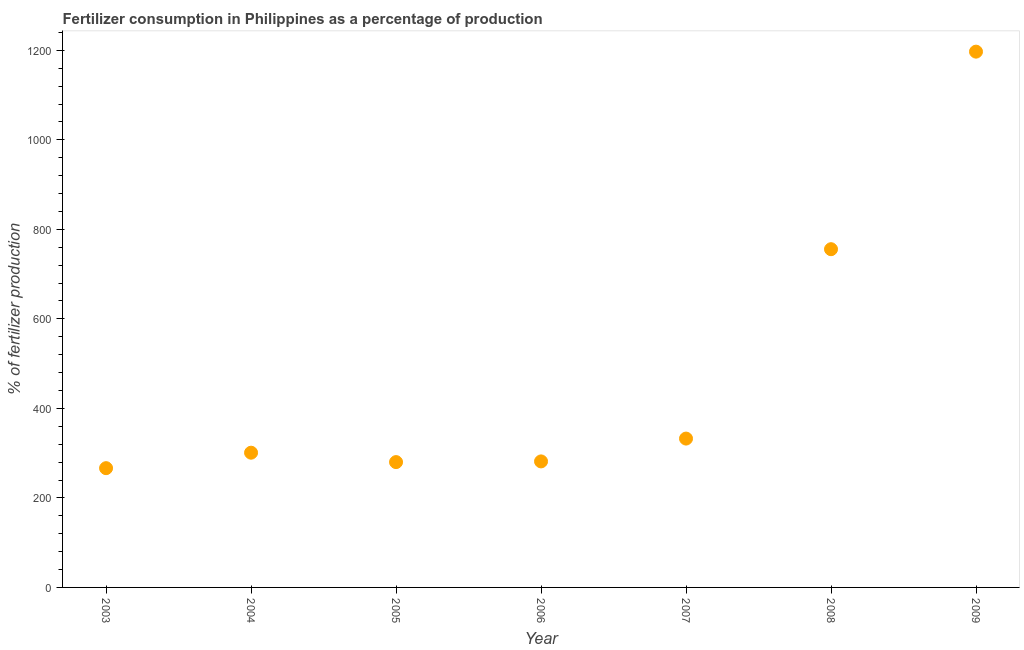What is the amount of fertilizer consumption in 2008?
Provide a short and direct response. 755.74. Across all years, what is the maximum amount of fertilizer consumption?
Provide a short and direct response. 1197.15. Across all years, what is the minimum amount of fertilizer consumption?
Make the answer very short. 266.48. In which year was the amount of fertilizer consumption maximum?
Your answer should be very brief. 2009. What is the sum of the amount of fertilizer consumption?
Offer a terse response. 3414.62. What is the difference between the amount of fertilizer consumption in 2004 and 2007?
Provide a succinct answer. -31.55. What is the average amount of fertilizer consumption per year?
Offer a terse response. 487.8. What is the median amount of fertilizer consumption?
Provide a succinct answer. 301.04. What is the ratio of the amount of fertilizer consumption in 2008 to that in 2009?
Your answer should be very brief. 0.63. What is the difference between the highest and the second highest amount of fertilizer consumption?
Keep it short and to the point. 441.41. What is the difference between the highest and the lowest amount of fertilizer consumption?
Your response must be concise. 930.67. How many years are there in the graph?
Provide a short and direct response. 7. Does the graph contain any zero values?
Provide a succinct answer. No. What is the title of the graph?
Keep it short and to the point. Fertilizer consumption in Philippines as a percentage of production. What is the label or title of the X-axis?
Provide a short and direct response. Year. What is the label or title of the Y-axis?
Ensure brevity in your answer.  % of fertilizer production. What is the % of fertilizer production in 2003?
Keep it short and to the point. 266.48. What is the % of fertilizer production in 2004?
Your answer should be compact. 301.04. What is the % of fertilizer production in 2005?
Give a very brief answer. 280.04. What is the % of fertilizer production in 2006?
Offer a terse response. 281.59. What is the % of fertilizer production in 2007?
Your answer should be very brief. 332.59. What is the % of fertilizer production in 2008?
Ensure brevity in your answer.  755.74. What is the % of fertilizer production in 2009?
Offer a terse response. 1197.15. What is the difference between the % of fertilizer production in 2003 and 2004?
Keep it short and to the point. -34.56. What is the difference between the % of fertilizer production in 2003 and 2005?
Your answer should be compact. -13.56. What is the difference between the % of fertilizer production in 2003 and 2006?
Make the answer very short. -15.11. What is the difference between the % of fertilizer production in 2003 and 2007?
Keep it short and to the point. -66.11. What is the difference between the % of fertilizer production in 2003 and 2008?
Keep it short and to the point. -489.26. What is the difference between the % of fertilizer production in 2003 and 2009?
Ensure brevity in your answer.  -930.67. What is the difference between the % of fertilizer production in 2004 and 2005?
Keep it short and to the point. 21. What is the difference between the % of fertilizer production in 2004 and 2006?
Make the answer very short. 19.45. What is the difference between the % of fertilizer production in 2004 and 2007?
Your response must be concise. -31.55. What is the difference between the % of fertilizer production in 2004 and 2008?
Ensure brevity in your answer.  -454.7. What is the difference between the % of fertilizer production in 2004 and 2009?
Offer a terse response. -896.11. What is the difference between the % of fertilizer production in 2005 and 2006?
Keep it short and to the point. -1.55. What is the difference between the % of fertilizer production in 2005 and 2007?
Your response must be concise. -52.55. What is the difference between the % of fertilizer production in 2005 and 2008?
Keep it short and to the point. -475.7. What is the difference between the % of fertilizer production in 2005 and 2009?
Ensure brevity in your answer.  -917.11. What is the difference between the % of fertilizer production in 2006 and 2007?
Keep it short and to the point. -51. What is the difference between the % of fertilizer production in 2006 and 2008?
Your answer should be very brief. -474.15. What is the difference between the % of fertilizer production in 2006 and 2009?
Offer a very short reply. -915.56. What is the difference between the % of fertilizer production in 2007 and 2008?
Make the answer very short. -423.15. What is the difference between the % of fertilizer production in 2007 and 2009?
Offer a terse response. -864.56. What is the difference between the % of fertilizer production in 2008 and 2009?
Your answer should be very brief. -441.41. What is the ratio of the % of fertilizer production in 2003 to that in 2004?
Keep it short and to the point. 0.89. What is the ratio of the % of fertilizer production in 2003 to that in 2006?
Your answer should be compact. 0.95. What is the ratio of the % of fertilizer production in 2003 to that in 2007?
Provide a succinct answer. 0.8. What is the ratio of the % of fertilizer production in 2003 to that in 2008?
Make the answer very short. 0.35. What is the ratio of the % of fertilizer production in 2003 to that in 2009?
Keep it short and to the point. 0.22. What is the ratio of the % of fertilizer production in 2004 to that in 2005?
Your answer should be compact. 1.07. What is the ratio of the % of fertilizer production in 2004 to that in 2006?
Provide a short and direct response. 1.07. What is the ratio of the % of fertilizer production in 2004 to that in 2007?
Ensure brevity in your answer.  0.91. What is the ratio of the % of fertilizer production in 2004 to that in 2008?
Ensure brevity in your answer.  0.4. What is the ratio of the % of fertilizer production in 2004 to that in 2009?
Give a very brief answer. 0.25. What is the ratio of the % of fertilizer production in 2005 to that in 2006?
Your answer should be compact. 0.99. What is the ratio of the % of fertilizer production in 2005 to that in 2007?
Provide a succinct answer. 0.84. What is the ratio of the % of fertilizer production in 2005 to that in 2008?
Ensure brevity in your answer.  0.37. What is the ratio of the % of fertilizer production in 2005 to that in 2009?
Offer a very short reply. 0.23. What is the ratio of the % of fertilizer production in 2006 to that in 2007?
Offer a very short reply. 0.85. What is the ratio of the % of fertilizer production in 2006 to that in 2008?
Provide a succinct answer. 0.37. What is the ratio of the % of fertilizer production in 2006 to that in 2009?
Ensure brevity in your answer.  0.23. What is the ratio of the % of fertilizer production in 2007 to that in 2008?
Your answer should be compact. 0.44. What is the ratio of the % of fertilizer production in 2007 to that in 2009?
Provide a succinct answer. 0.28. What is the ratio of the % of fertilizer production in 2008 to that in 2009?
Keep it short and to the point. 0.63. 